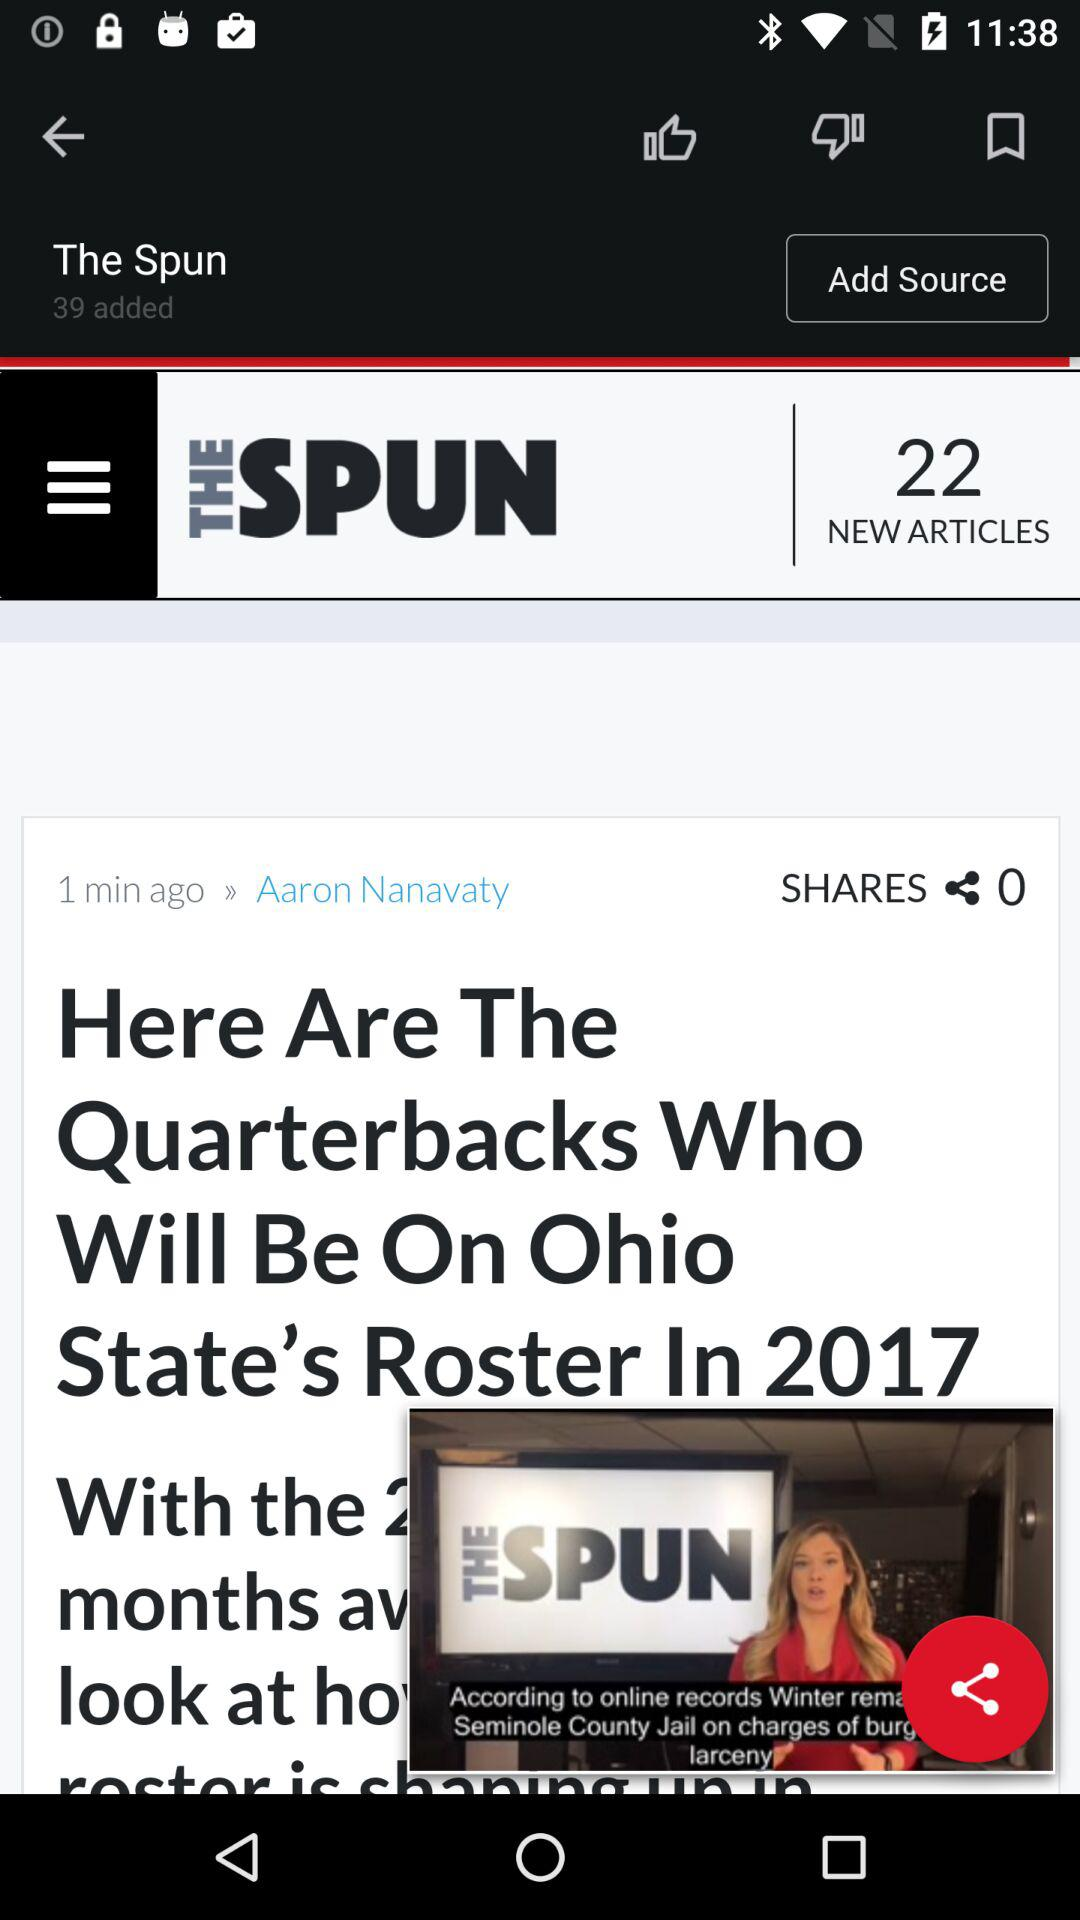How many new articles are there? There are 22 new articles. 